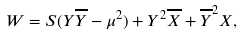<formula> <loc_0><loc_0><loc_500><loc_500>W = S ( Y \overline { Y } - \mu ^ { 2 } ) + Y ^ { 2 } \overline { X } + \overline { Y } ^ { 2 } X ,</formula> 